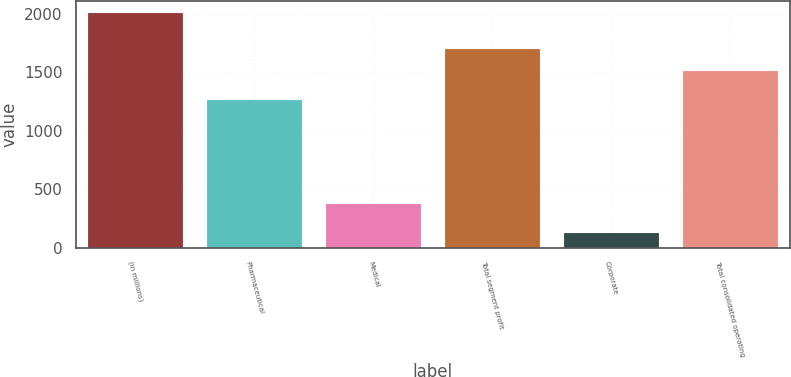Convert chart. <chart><loc_0><loc_0><loc_500><loc_500><bar_chart><fcel>(in millions)<fcel>Pharmaceutical<fcel>Medical<fcel>Total segment profit<fcel>Corporate<fcel>Total consolidated operating<nl><fcel>2011<fcel>1264.8<fcel>369.9<fcel>1703.03<fcel>120.7<fcel>1514<nl></chart> 